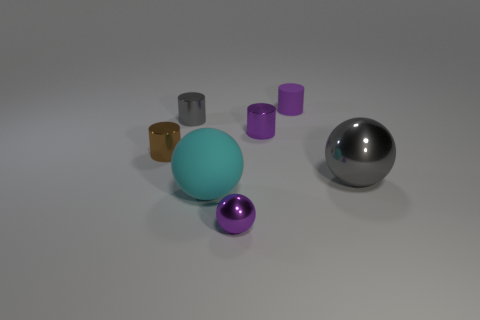Is there a tiny blue sphere?
Give a very brief answer. No. The gray object right of the purple object that is left of the small shiny cylinder that is to the right of the tiny sphere is what shape?
Your answer should be compact. Sphere. There is a large cyan rubber sphere; what number of small metallic spheres are in front of it?
Offer a very short reply. 1. Does the purple thing in front of the brown object have the same material as the big gray ball?
Your answer should be compact. Yes. What number of other objects are the same shape as the large cyan object?
Offer a very short reply. 2. There is a gray thing that is in front of the tiny purple cylinder left of the purple matte object; how many big shiny balls are in front of it?
Provide a short and direct response. 0. The sphere that is behind the cyan matte thing is what color?
Provide a short and direct response. Gray. There is a small metallic cylinder that is behind the small purple metallic cylinder; is its color the same as the big metal object?
Provide a succinct answer. Yes. There is another purple thing that is the same shape as the small matte object; what size is it?
Provide a succinct answer. Small. What is the small purple cylinder that is behind the tiny metal cylinder behind the small purple cylinder left of the purple matte cylinder made of?
Your response must be concise. Rubber. 